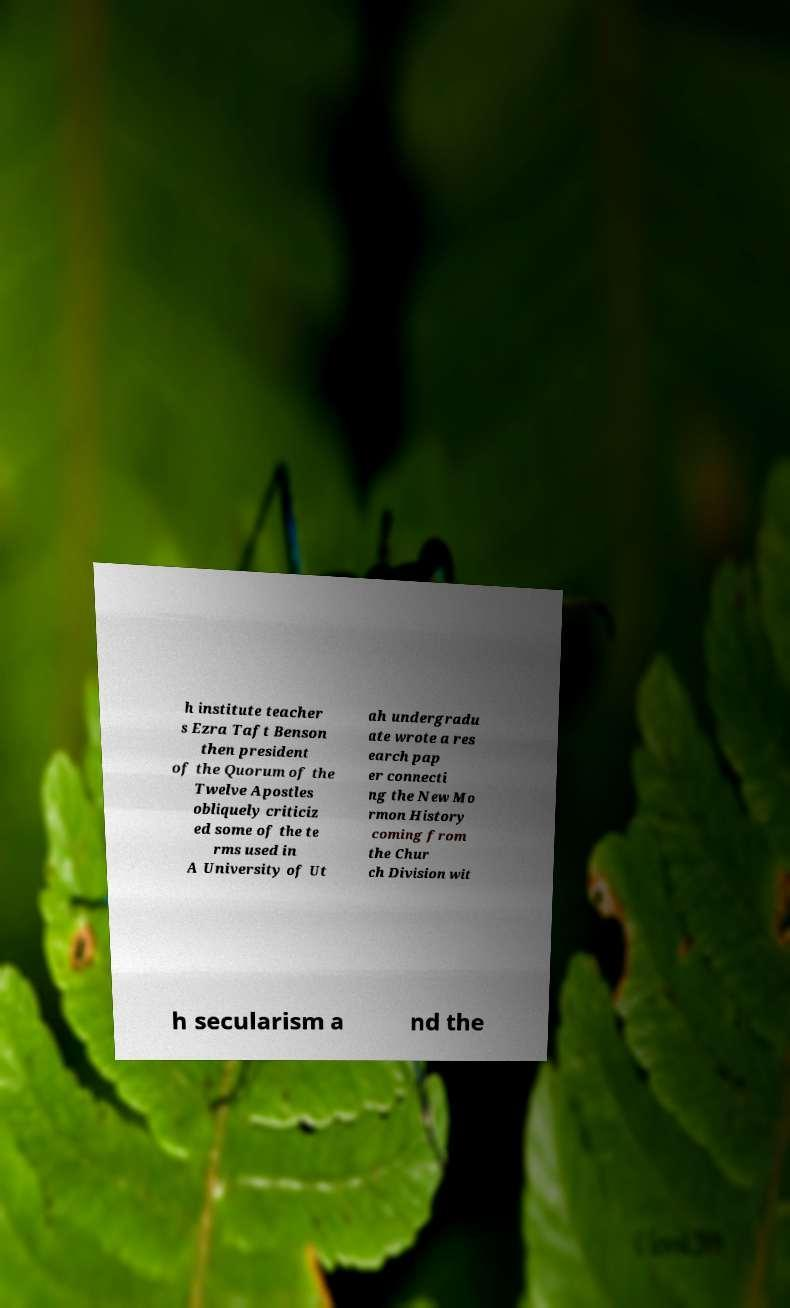For documentation purposes, I need the text within this image transcribed. Could you provide that? h institute teacher s Ezra Taft Benson then president of the Quorum of the Twelve Apostles obliquely criticiz ed some of the te rms used in A University of Ut ah undergradu ate wrote a res earch pap er connecti ng the New Mo rmon History coming from the Chur ch Division wit h secularism a nd the 